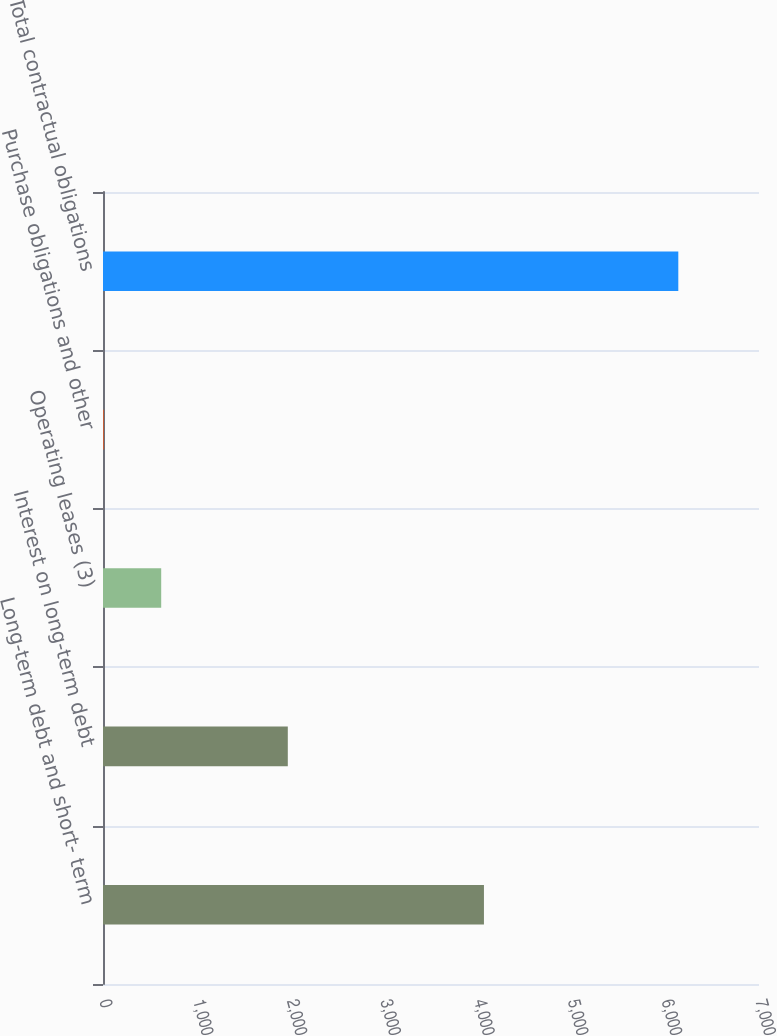<chart> <loc_0><loc_0><loc_500><loc_500><bar_chart><fcel>Long-term debt and short- term<fcel>Interest on long-term debt<fcel>Operating leases (3)<fcel>Purchase obligations and other<fcel>Total contractual obligations<nl><fcel>4065<fcel>1972<fcel>621.1<fcel>8<fcel>6139<nl></chart> 